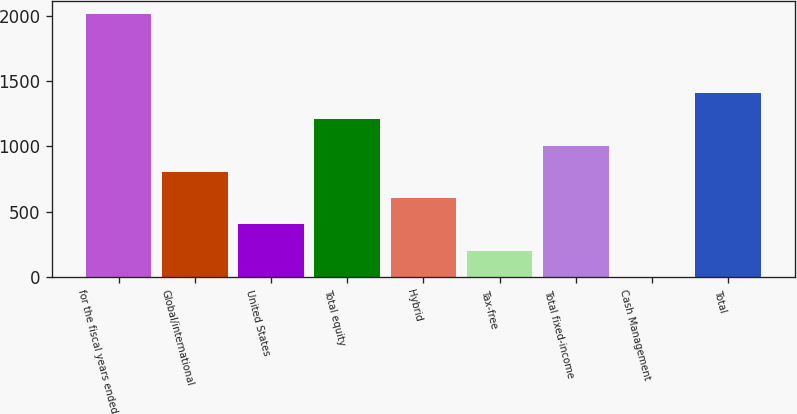<chart> <loc_0><loc_0><loc_500><loc_500><bar_chart><fcel>for the fiscal years ended<fcel>Global/international<fcel>United States<fcel>Total equity<fcel>Hybrid<fcel>Tax-free<fcel>Total fixed-income<fcel>Cash Management<fcel>Total<nl><fcel>2011<fcel>805<fcel>403<fcel>1207<fcel>604<fcel>202<fcel>1006<fcel>1<fcel>1408<nl></chart> 